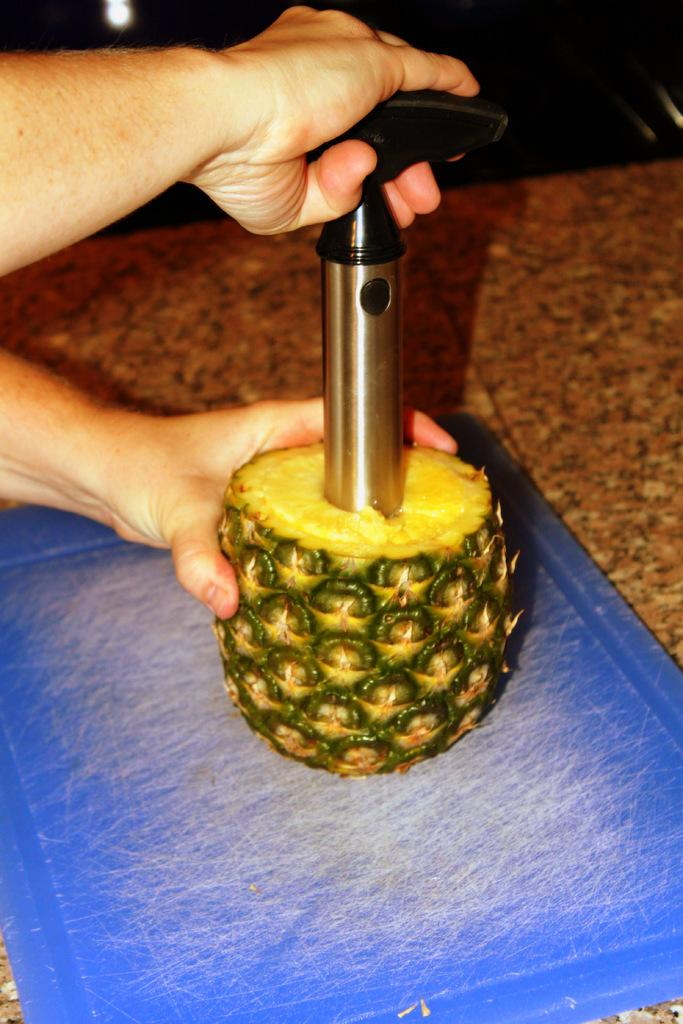What is the object being held by the human hands in the image? There is no specific object mentioned in the facts, but we know that one hand is holding an object. What fruit is being held by the other hand in the image? The other hand is holding a pineapple in the image. What surface is the chopping board placed on? The chopping board is placed on a marble surface in the image. What disease is being discussed in the image? There is no mention of a disease in the image, as it primarily focuses on hands holding objects and a pineapple. 